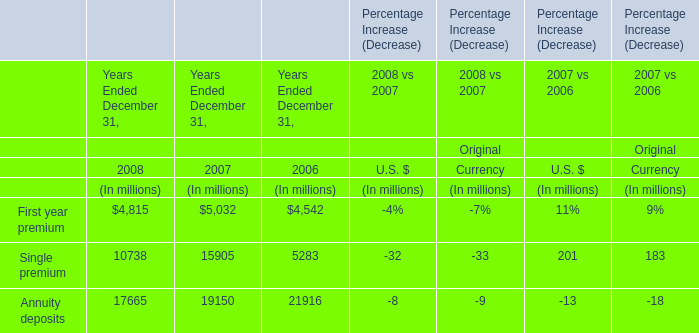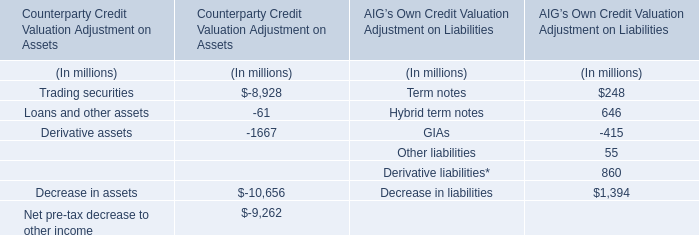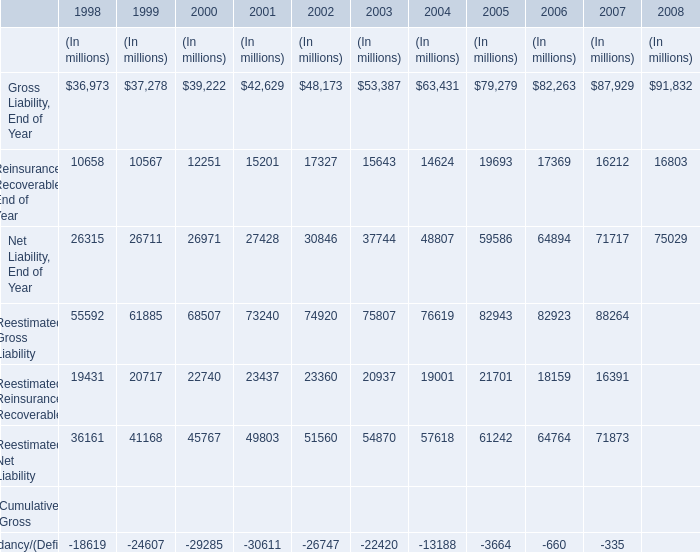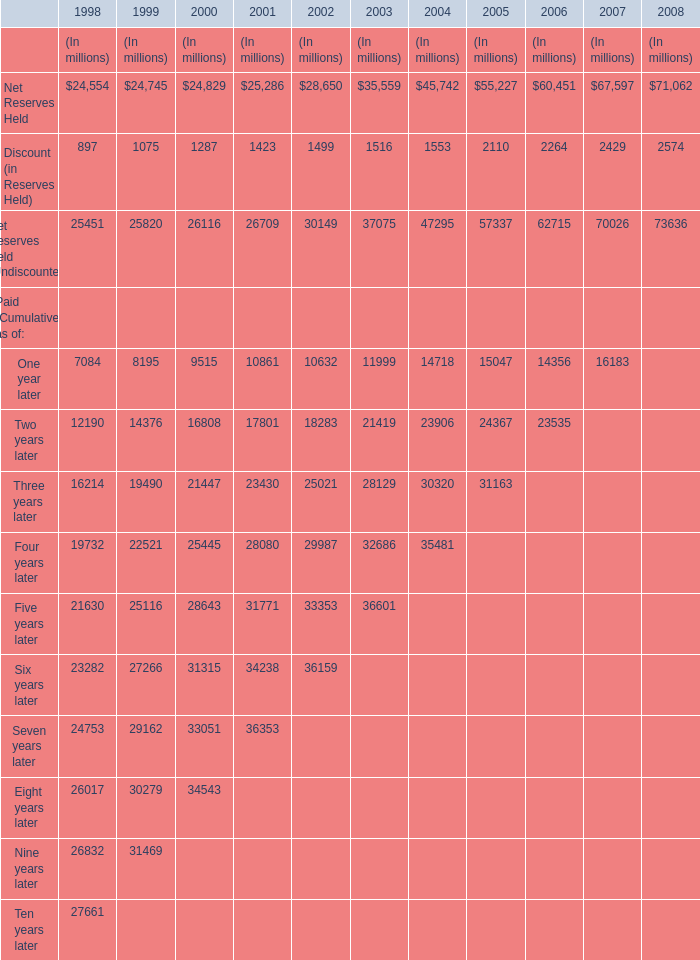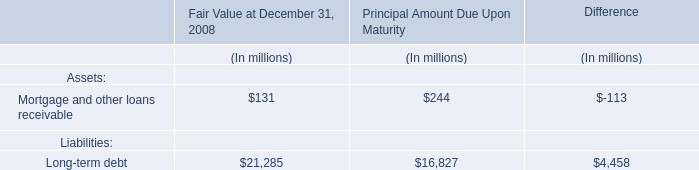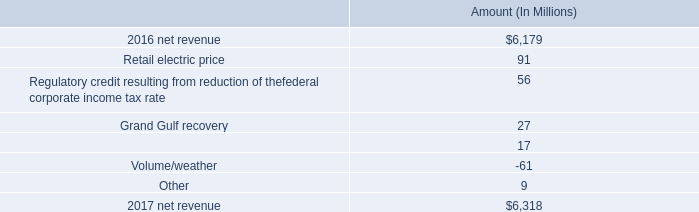What's the increasing rate of Net Reserves Held in 1999? 
Computations: ((24745 - 24554) / 24554)
Answer: 0.00778. 